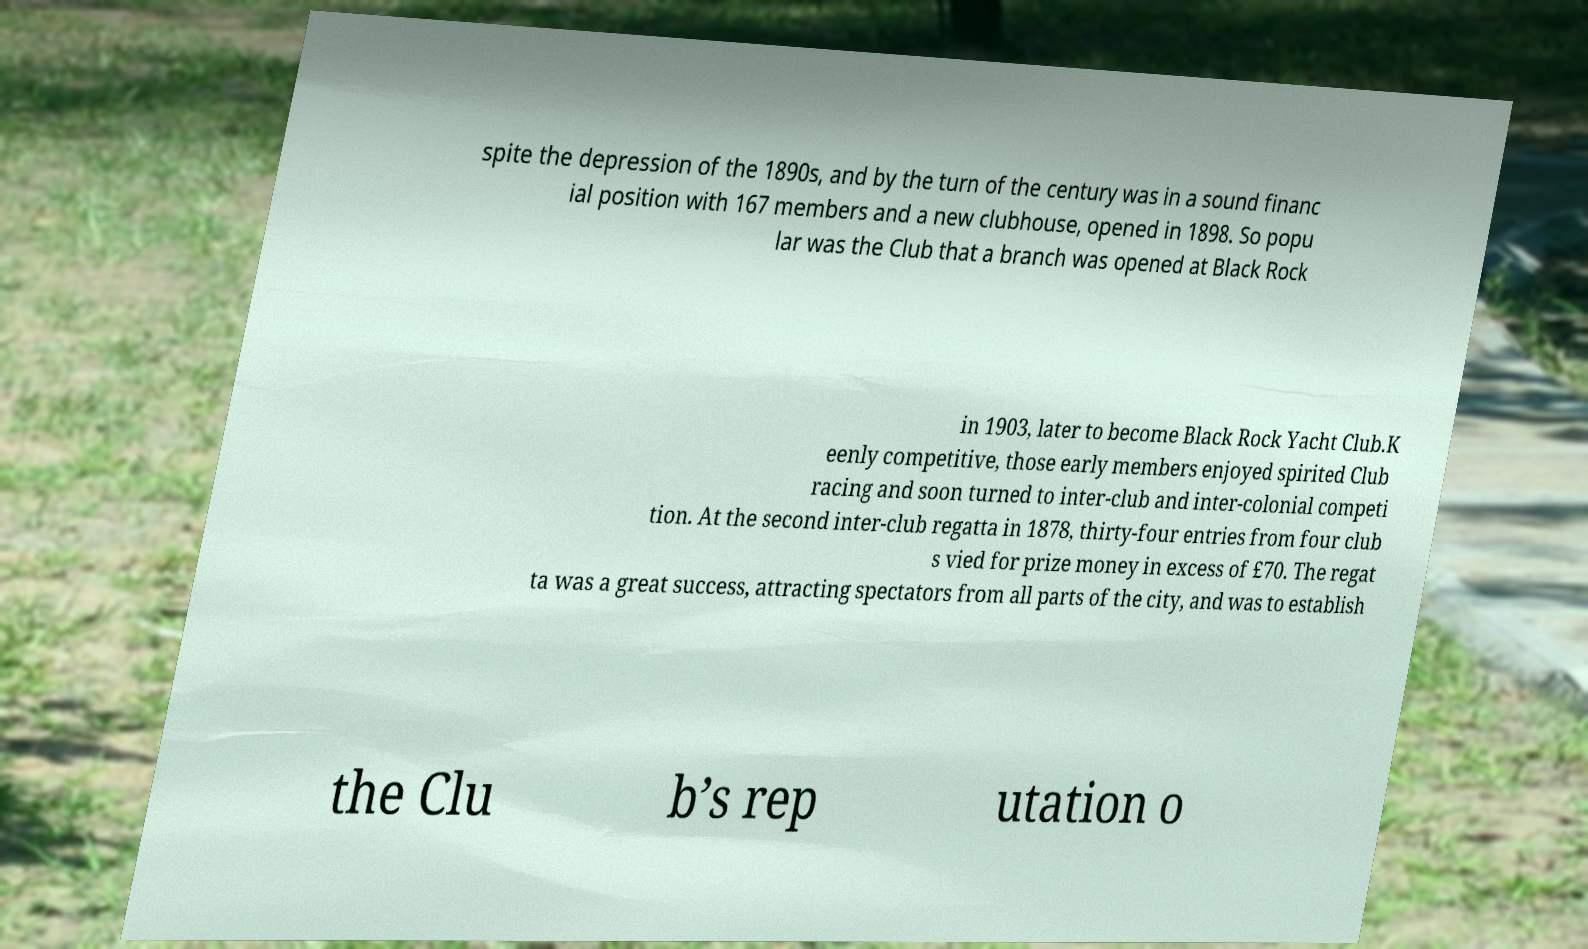Please identify and transcribe the text found in this image. spite the depression of the 1890s, and by the turn of the century was in a sound financ ial position with 167 members and a new clubhouse, opened in 1898. So popu lar was the Club that a branch was opened at Black Rock in 1903, later to become Black Rock Yacht Club.K eenly competitive, those early members enjoyed spirited Club racing and soon turned to inter-club and inter-colonial competi tion. At the second inter-club regatta in 1878, thirty-four entries from four club s vied for prize money in excess of £70. The regat ta was a great success, attracting spectators from all parts of the city, and was to establish the Clu b’s rep utation o 